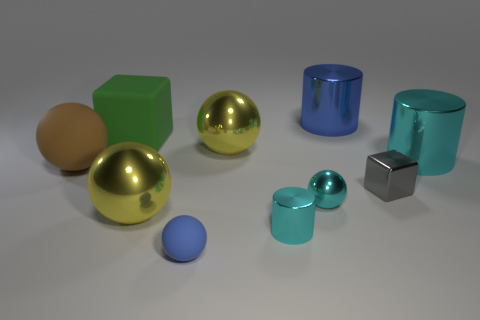Subtract all cyan shiny spheres. How many spheres are left? 4 Subtract all brown spheres. How many spheres are left? 4 Subtract all brown spheres. Subtract all green cubes. How many spheres are left? 4 Subtract all blocks. How many objects are left? 8 Add 4 big green matte things. How many big green matte things exist? 5 Subtract 1 gray cubes. How many objects are left? 9 Subtract all big green things. Subtract all small cyan metallic cylinders. How many objects are left? 8 Add 1 metallic balls. How many metallic balls are left? 4 